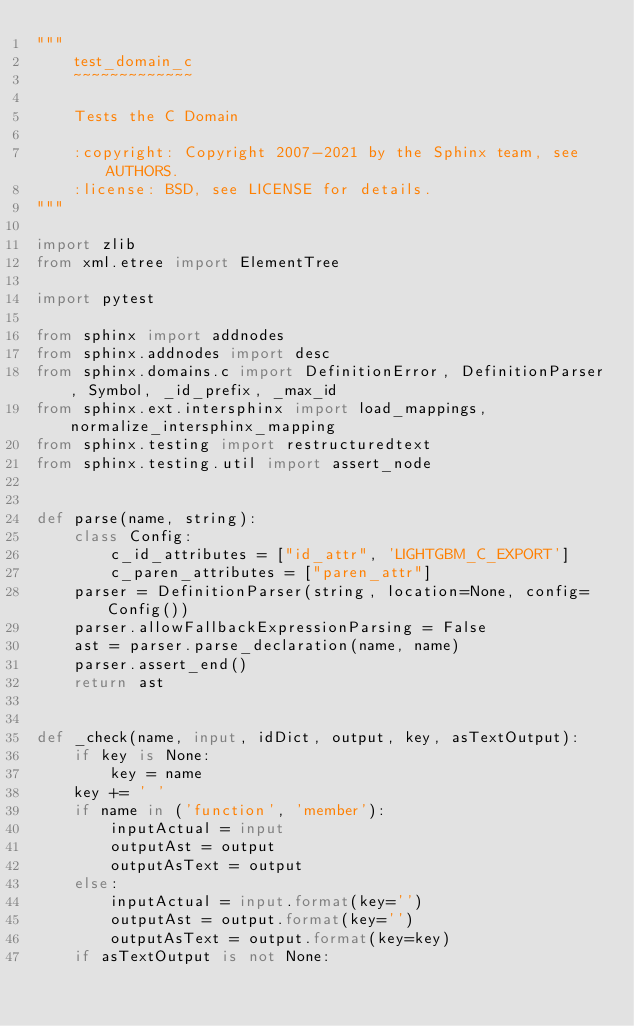Convert code to text. <code><loc_0><loc_0><loc_500><loc_500><_Python_>"""
    test_domain_c
    ~~~~~~~~~~~~~

    Tests the C Domain

    :copyright: Copyright 2007-2021 by the Sphinx team, see AUTHORS.
    :license: BSD, see LICENSE for details.
"""

import zlib
from xml.etree import ElementTree

import pytest

from sphinx import addnodes
from sphinx.addnodes import desc
from sphinx.domains.c import DefinitionError, DefinitionParser, Symbol, _id_prefix, _max_id
from sphinx.ext.intersphinx import load_mappings, normalize_intersphinx_mapping
from sphinx.testing import restructuredtext
from sphinx.testing.util import assert_node


def parse(name, string):
    class Config:
        c_id_attributes = ["id_attr", 'LIGHTGBM_C_EXPORT']
        c_paren_attributes = ["paren_attr"]
    parser = DefinitionParser(string, location=None, config=Config())
    parser.allowFallbackExpressionParsing = False
    ast = parser.parse_declaration(name, name)
    parser.assert_end()
    return ast


def _check(name, input, idDict, output, key, asTextOutput):
    if key is None:
        key = name
    key += ' '
    if name in ('function', 'member'):
        inputActual = input
        outputAst = output
        outputAsText = output
    else:
        inputActual = input.format(key='')
        outputAst = output.format(key='')
        outputAsText = output.format(key=key)
    if asTextOutput is not None:</code> 